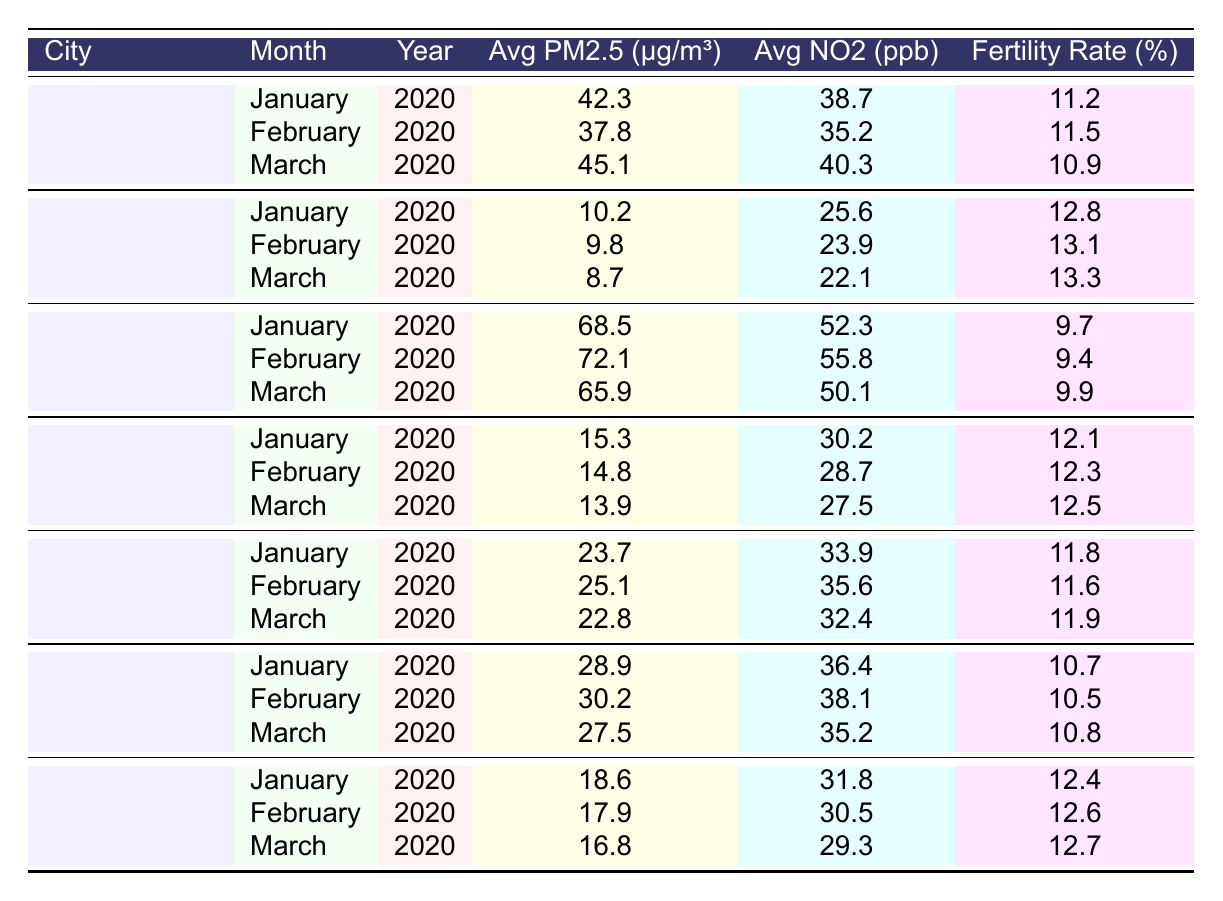What is the fertility rate in Beijing for January 2020? The table shows the fertility rate for Beijing in January 2020 as 11.2%.
Answer: 11.2% Which month had the highest average PM2.5 level in Mumbai? In the table, January had an average PM2.5 of 68.5 μg/m³, which is higher than February (72.1) or March (65.9).
Answer: January What city had the lowest fertility rate recorded in the table? By examining the fertility rates in the table, Mumbai had the lowest fertility rate of 9.4% in February 2020.
Answer: Mumbai What is the average fertility rate for New York City over the three months? The fertility rates for New York City are 12.8%, 13.1%, and 13.3%. Summing these gives 39.2%, and dividing by 3 leads to an average of 13.07%.
Answer: 13.07% Is the average NO2 level in Paris lower than in London for all recorded months? The average NO2 levels for Paris are 31.8, 30.5, and 29.3 ppb, while for London, they are 30.2, 28.7, and 27.5 ppb. In all months, Paris's values are higher.
Answer: No What is the difference in average fertility rates between Mumbai and New York City? Mumbai's average fertility rate is (9.7 + 9.4 + 9.9) / 3 = 9.67%, and New York City's is (12.8 + 13.1 + 13.3) / 3 = 13.07%. The difference is 13.07 - 9.67 = 3.4%.
Answer: 3.4% Which city has the highest average NO2 level across the recorded months? By examining the average NO2 values, Mumbai has values of 52.3, 55.8, and 50.1 ppb, which are all higher than any other city listed.
Answer: Mumbai What is the average PM2.5 level for March in all the cities? The average PM2.5 levels for March are 45.1, 8.7, 65.9, 13.9, 22.8, 27.5, and 16.8 μg/m³. The total is 200.8 μg/m³ divided by 7 gives an average of approximately 28.7 μg/m³.
Answer: 28.7 In which month did Seoul have the highest fertility rate? Checking the fertility rates for Seoul shows that the highest is 10.8% in March.
Answer: March Is Beijing's average PM2.5 for January greater than the average of all cities listed for that month? For January, the average PM2.5 values are Beijing (42.3), New York City (10.2), Mumbai (68.5), London (15.3), Mexico City (23.7), Seoul (28.9), and Paris (18.6). The average of these is 26.1 μg/m³, which is less than Beijing's.
Answer: Yes What trends can be observed in fertility rates as PM2.5 levels increase in urban areas, based on the table? As average PM2.5 levels rise, such as in Mumbai, fertility rates generally decrease compared to cities like New York City, which have lower PM2.5 and higher fertility rates, indicating a potential adverse effect of pollution on fertility.
Answer: Negative correlation 